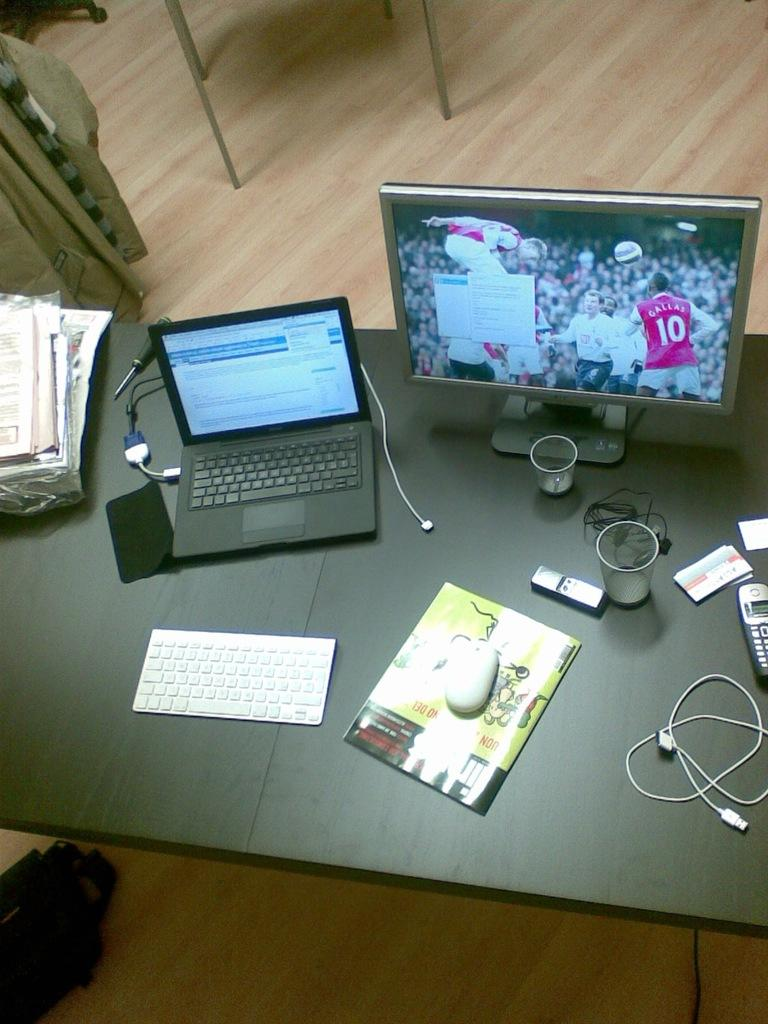<image>
Create a compact narrative representing the image presented. A desk has a laptop and a monitor on it showing a soccer player with the name Gallas on his uniform. 